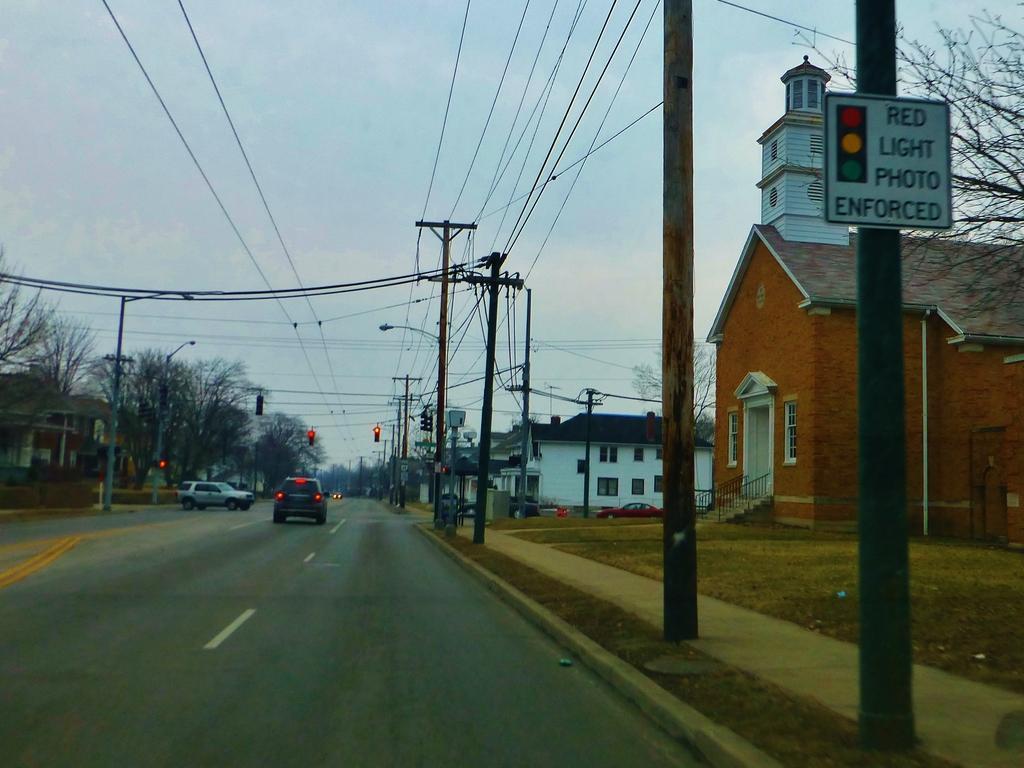In one or two sentences, can you explain what this image depicts? In this image we can see cars on the road. On the both sides of the road, we can see people's, houses and trees. At the top of the image, we can see the wires and the sky. There is a board on the right side of the image. 